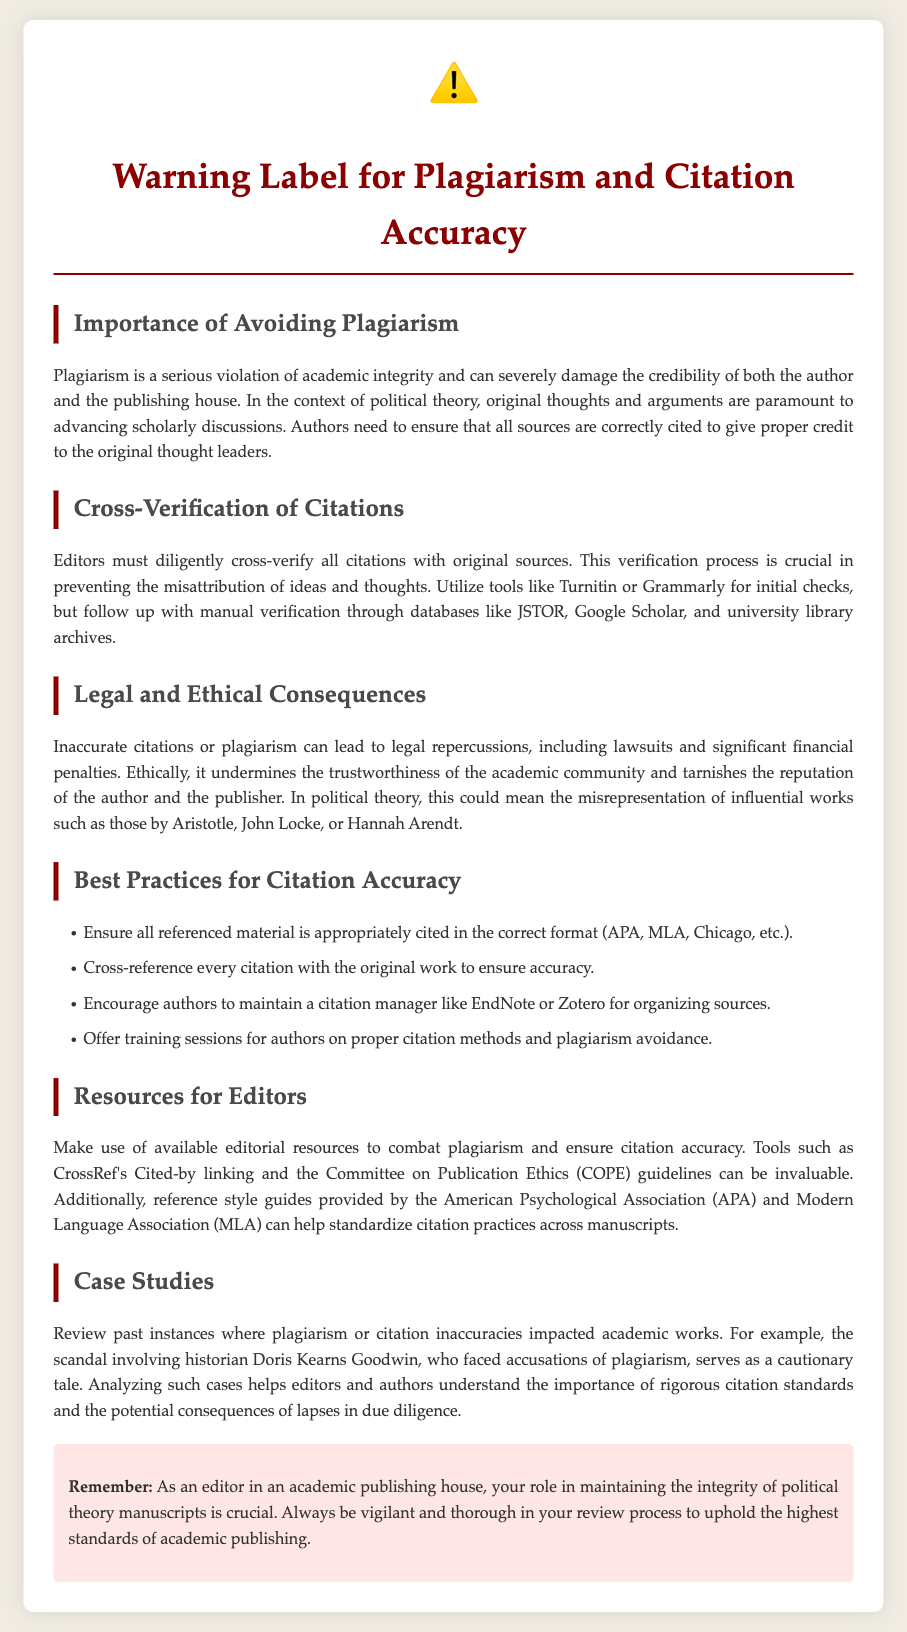what is the title of the document? The title is mentioned at the top of the document, indicating the main focus of the content.
Answer: Warning Label for Plagiarism and Citation Accuracy what icon is used in the document? The icon is included prominently at the beginning of the document to draw attention to the warning.
Answer: ⚠️ how many best practices for citation accuracy are listed? The document enumerates a specific section that provides recommendations for citation accuracy.
Answer: Four what format is suggested for citations? The document mentions various citation formats that can be used for accuracy.
Answer: APA, MLA, Chicago what is the main consequence of plagiarism mentioned? A serious outcome is cited, which affects both the author and the publisher in terms of legal standing.
Answer: Legal repercussions what should editors use to verify citations? The document highlights specific tools that can assist editors in ensuring the validity of citations.
Answer: JSTOR, Google Scholar who is mentioned as an example of plagiarism consequences? The document offers a notable case study from history to illustrate the risks of poor citation practices.
Answer: Doris Kearns Goodwin what is the importance of cross-verification? The document discusses the necessity of verifying citations to avoid errors in attribution.
Answer: Preventing misattribution of ideas what type of resources for editors are mentioned? The document recommends various types of resources that can assist in maintaining citation accuracy.
Answer: Editorial resources, style guides 